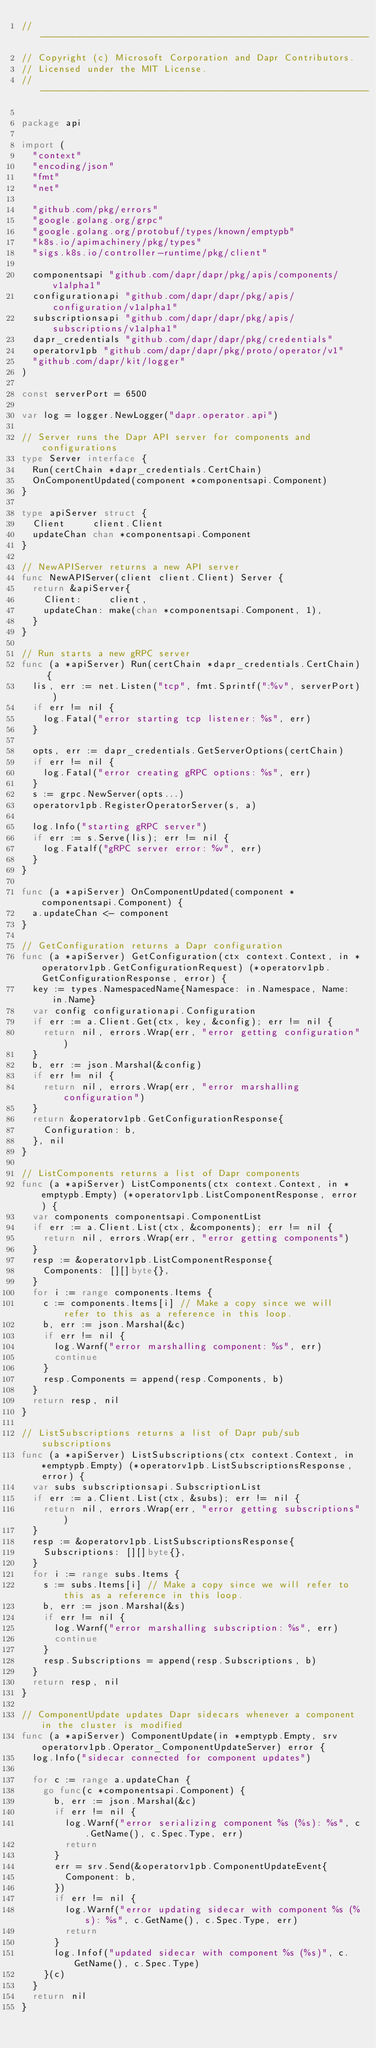<code> <loc_0><loc_0><loc_500><loc_500><_Go_>// ------------------------------------------------------------
// Copyright (c) Microsoft Corporation and Dapr Contributors.
// Licensed under the MIT License.
// ------------------------------------------------------------

package api

import (
	"context"
	"encoding/json"
	"fmt"
	"net"

	"github.com/pkg/errors"
	"google.golang.org/grpc"
	"google.golang.org/protobuf/types/known/emptypb"
	"k8s.io/apimachinery/pkg/types"
	"sigs.k8s.io/controller-runtime/pkg/client"

	componentsapi "github.com/dapr/dapr/pkg/apis/components/v1alpha1"
	configurationapi "github.com/dapr/dapr/pkg/apis/configuration/v1alpha1"
	subscriptionsapi "github.com/dapr/dapr/pkg/apis/subscriptions/v1alpha1"
	dapr_credentials "github.com/dapr/dapr/pkg/credentials"
	operatorv1pb "github.com/dapr/dapr/pkg/proto/operator/v1"
	"github.com/dapr/kit/logger"
)

const serverPort = 6500

var log = logger.NewLogger("dapr.operator.api")

// Server runs the Dapr API server for components and configurations
type Server interface {
	Run(certChain *dapr_credentials.CertChain)
	OnComponentUpdated(component *componentsapi.Component)
}

type apiServer struct {
	Client     client.Client
	updateChan chan *componentsapi.Component
}

// NewAPIServer returns a new API server
func NewAPIServer(client client.Client) Server {
	return &apiServer{
		Client:     client,
		updateChan: make(chan *componentsapi.Component, 1),
	}
}

// Run starts a new gRPC server
func (a *apiServer) Run(certChain *dapr_credentials.CertChain) {
	lis, err := net.Listen("tcp", fmt.Sprintf(":%v", serverPort))
	if err != nil {
		log.Fatal("error starting tcp listener: %s", err)
	}

	opts, err := dapr_credentials.GetServerOptions(certChain)
	if err != nil {
		log.Fatal("error creating gRPC options: %s", err)
	}
	s := grpc.NewServer(opts...)
	operatorv1pb.RegisterOperatorServer(s, a)

	log.Info("starting gRPC server")
	if err := s.Serve(lis); err != nil {
		log.Fatalf("gRPC server error: %v", err)
	}
}

func (a *apiServer) OnComponentUpdated(component *componentsapi.Component) {
	a.updateChan <- component
}

// GetConfiguration returns a Dapr configuration
func (a *apiServer) GetConfiguration(ctx context.Context, in *operatorv1pb.GetConfigurationRequest) (*operatorv1pb.GetConfigurationResponse, error) {
	key := types.NamespacedName{Namespace: in.Namespace, Name: in.Name}
	var config configurationapi.Configuration
	if err := a.Client.Get(ctx, key, &config); err != nil {
		return nil, errors.Wrap(err, "error getting configuration")
	}
	b, err := json.Marshal(&config)
	if err != nil {
		return nil, errors.Wrap(err, "error marshalling configuration")
	}
	return &operatorv1pb.GetConfigurationResponse{
		Configuration: b,
	}, nil
}

// ListComponents returns a list of Dapr components
func (a *apiServer) ListComponents(ctx context.Context, in *emptypb.Empty) (*operatorv1pb.ListComponentResponse, error) {
	var components componentsapi.ComponentList
	if err := a.Client.List(ctx, &components); err != nil {
		return nil, errors.Wrap(err, "error getting components")
	}
	resp := &operatorv1pb.ListComponentResponse{
		Components: [][]byte{},
	}
	for i := range components.Items {
		c := components.Items[i] // Make a copy since we will refer to this as a reference in this loop.
		b, err := json.Marshal(&c)
		if err != nil {
			log.Warnf("error marshalling component: %s", err)
			continue
		}
		resp.Components = append(resp.Components, b)
	}
	return resp, nil
}

// ListSubscriptions returns a list of Dapr pub/sub subscriptions
func (a *apiServer) ListSubscriptions(ctx context.Context, in *emptypb.Empty) (*operatorv1pb.ListSubscriptionsResponse, error) {
	var subs subscriptionsapi.SubscriptionList
	if err := a.Client.List(ctx, &subs); err != nil {
		return nil, errors.Wrap(err, "error getting subscriptions")
	}
	resp := &operatorv1pb.ListSubscriptionsResponse{
		Subscriptions: [][]byte{},
	}
	for i := range subs.Items {
		s := subs.Items[i] // Make a copy since we will refer to this as a reference in this loop.
		b, err := json.Marshal(&s)
		if err != nil {
			log.Warnf("error marshalling subscription: %s", err)
			continue
		}
		resp.Subscriptions = append(resp.Subscriptions, b)
	}
	return resp, nil
}

// ComponentUpdate updates Dapr sidecars whenever a component in the cluster is modified
func (a *apiServer) ComponentUpdate(in *emptypb.Empty, srv operatorv1pb.Operator_ComponentUpdateServer) error {
	log.Info("sidecar connected for component updates")

	for c := range a.updateChan {
		go func(c *componentsapi.Component) {
			b, err := json.Marshal(&c)
			if err != nil {
				log.Warnf("error serializing component %s (%s): %s", c.GetName(), c.Spec.Type, err)
				return
			}
			err = srv.Send(&operatorv1pb.ComponentUpdateEvent{
				Component: b,
			})
			if err != nil {
				log.Warnf("error updating sidecar with component %s (%s): %s", c.GetName(), c.Spec.Type, err)
				return
			}
			log.Infof("updated sidecar with component %s (%s)", c.GetName(), c.Spec.Type)
		}(c)
	}
	return nil
}
</code> 